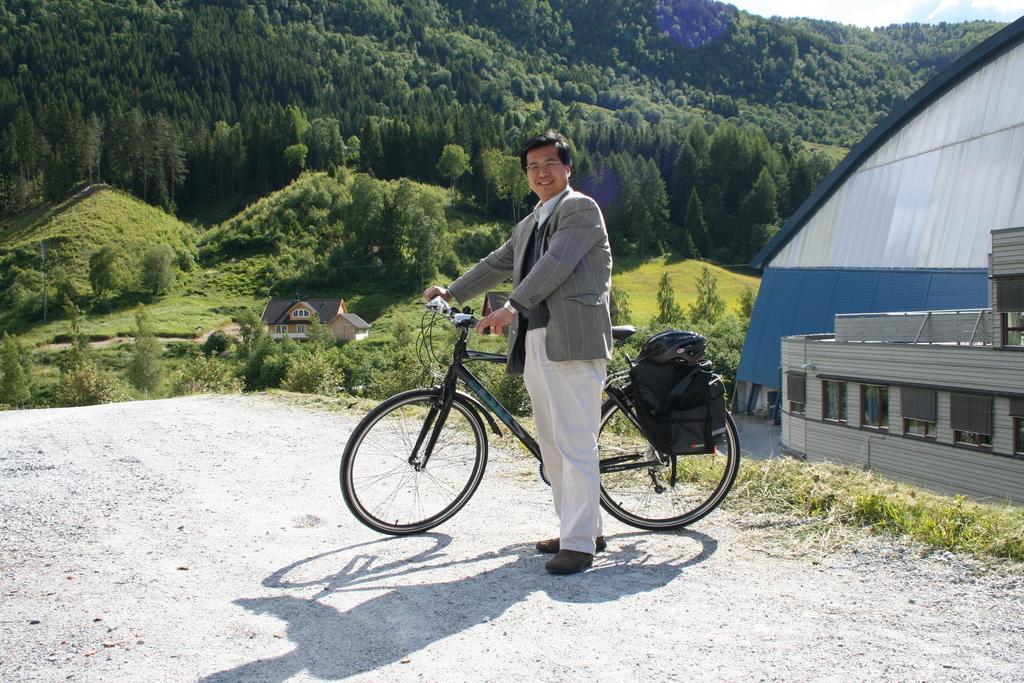Can you describe this image briefly? In this image we can see a man standing on the ground by holding a bicycle. In the background there are trees, shrubs, bushes, buildings and sky. 